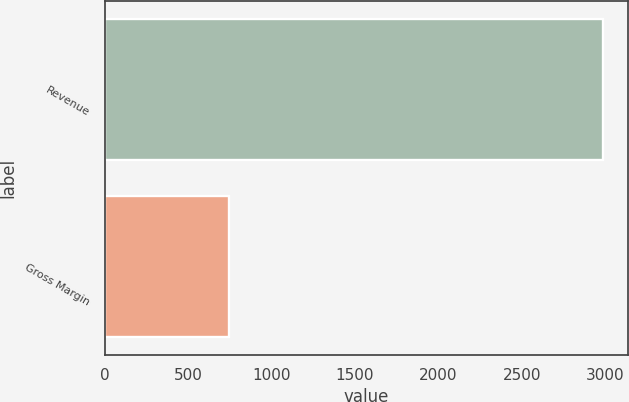<chart> <loc_0><loc_0><loc_500><loc_500><bar_chart><fcel>Revenue<fcel>Gross Margin<nl><fcel>2989<fcel>743<nl></chart> 